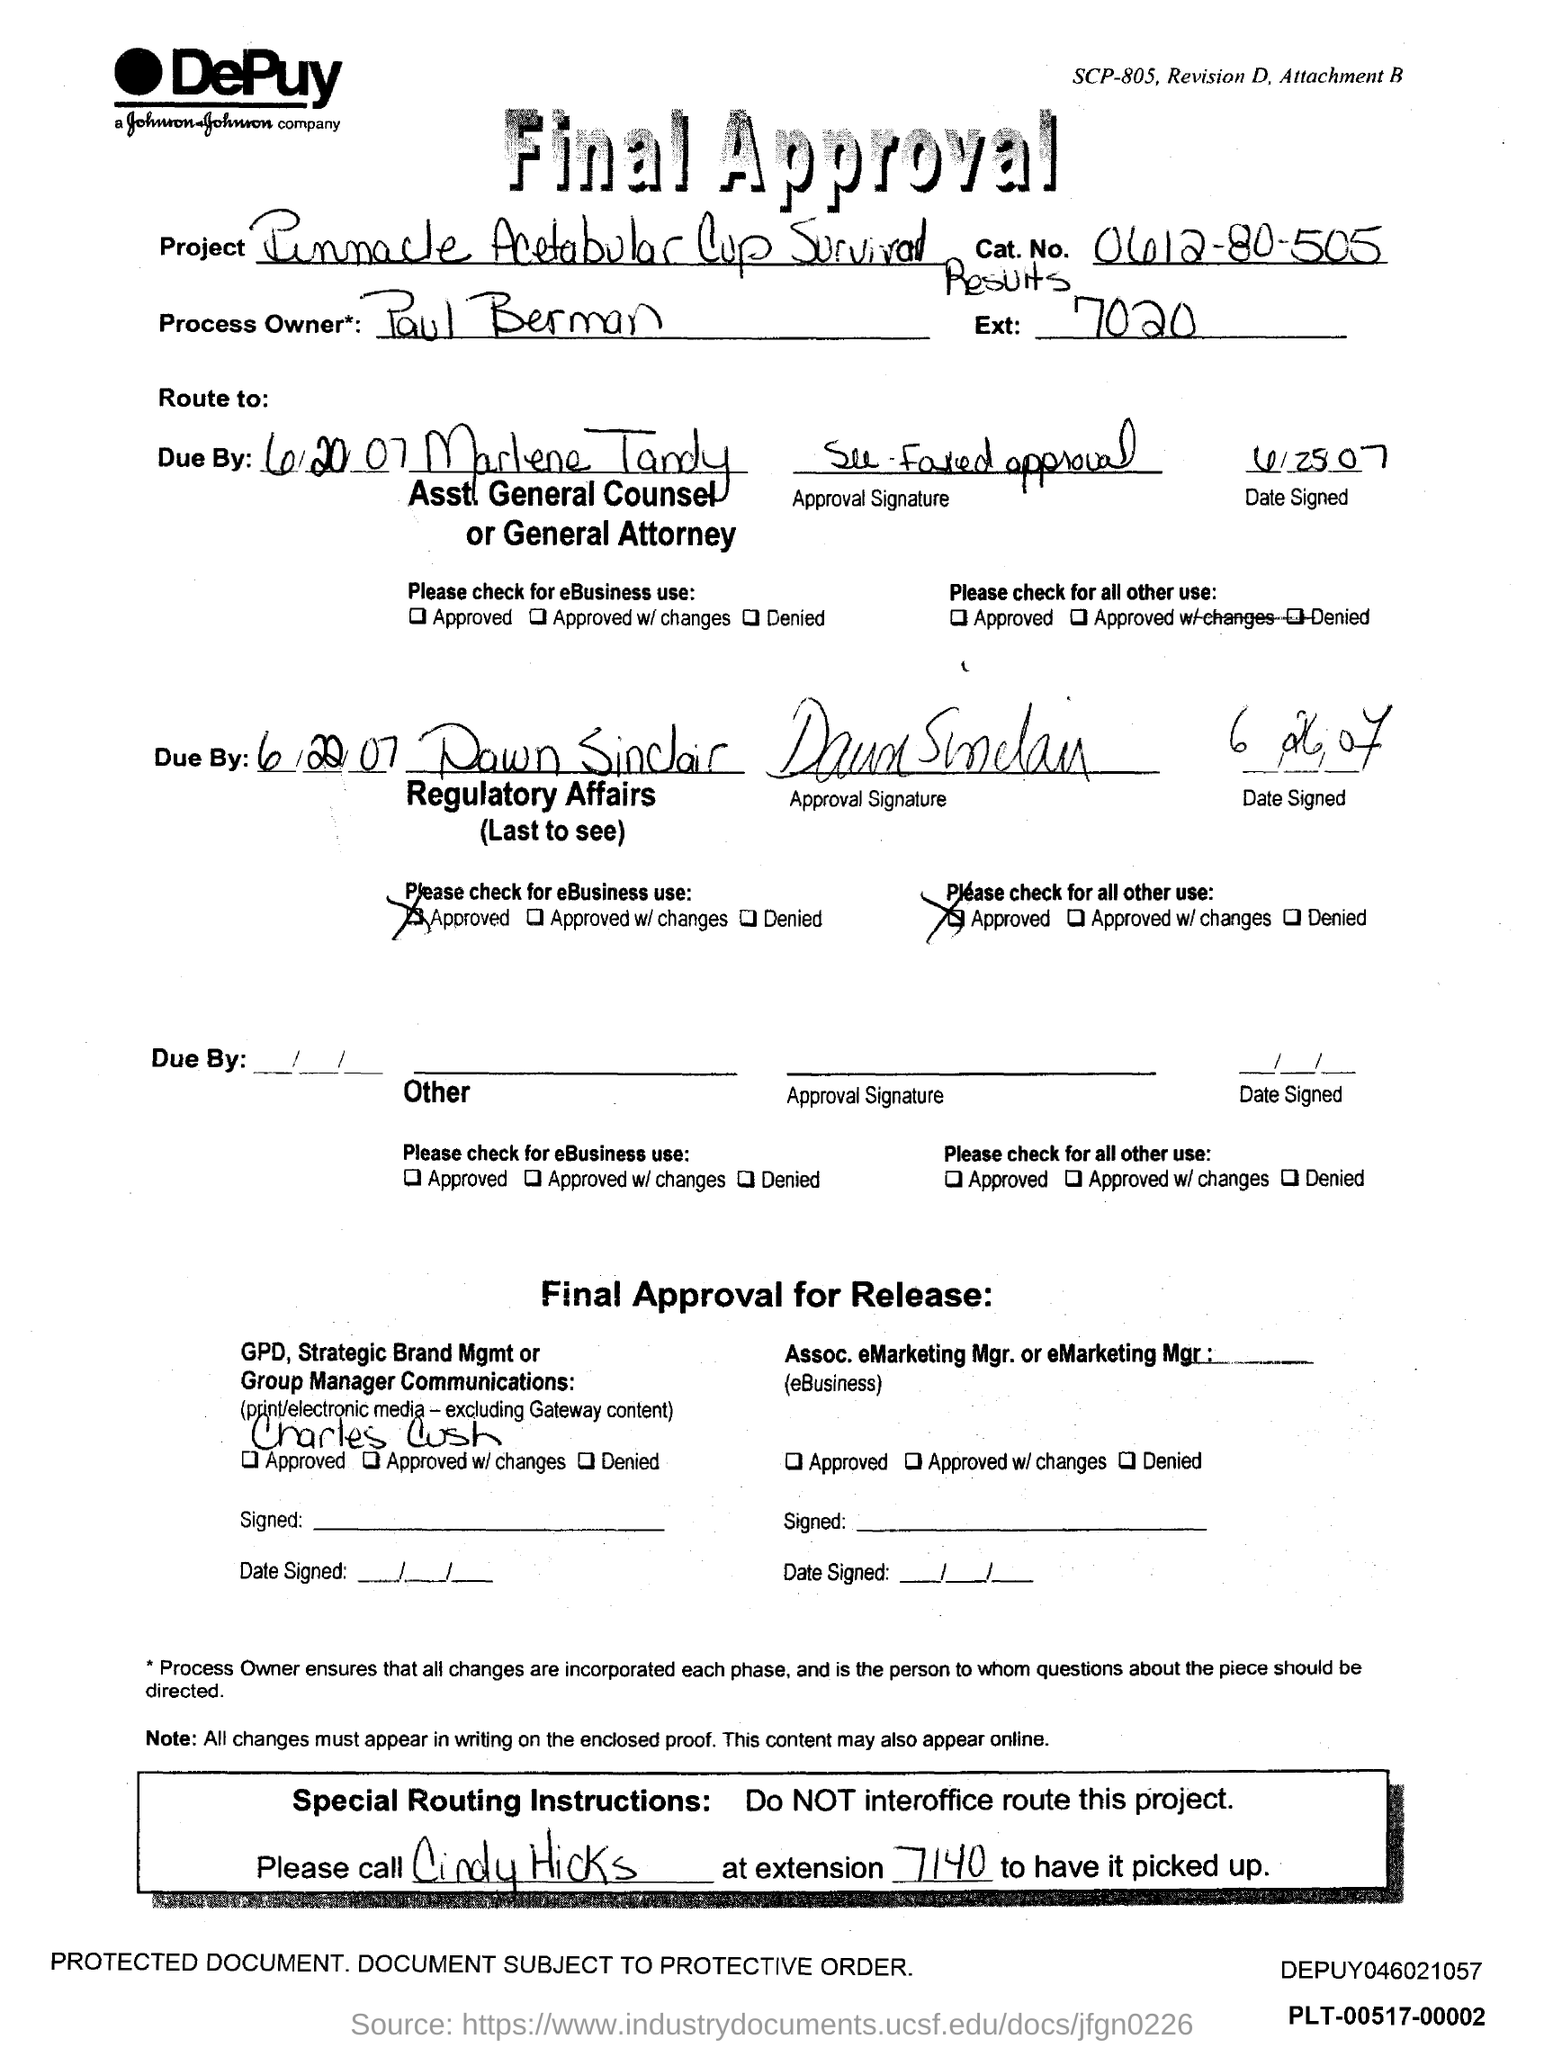What is the cat. no. ?
Make the answer very short. 0612-80-505. What is the ext no.?
Your answer should be compact. 7020. Who is the process owner*?
Keep it short and to the point. Paul Berman. 